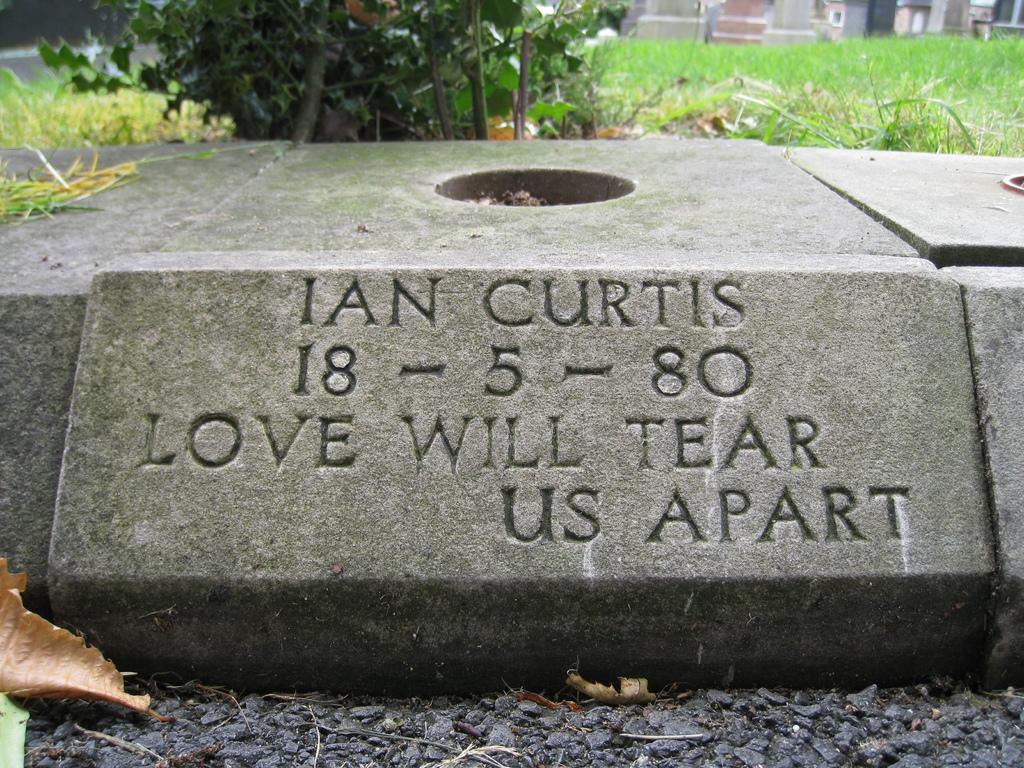Can you describe this image briefly? In this image I can see the rock. In the background I can see the plant, grass and the buildings. 